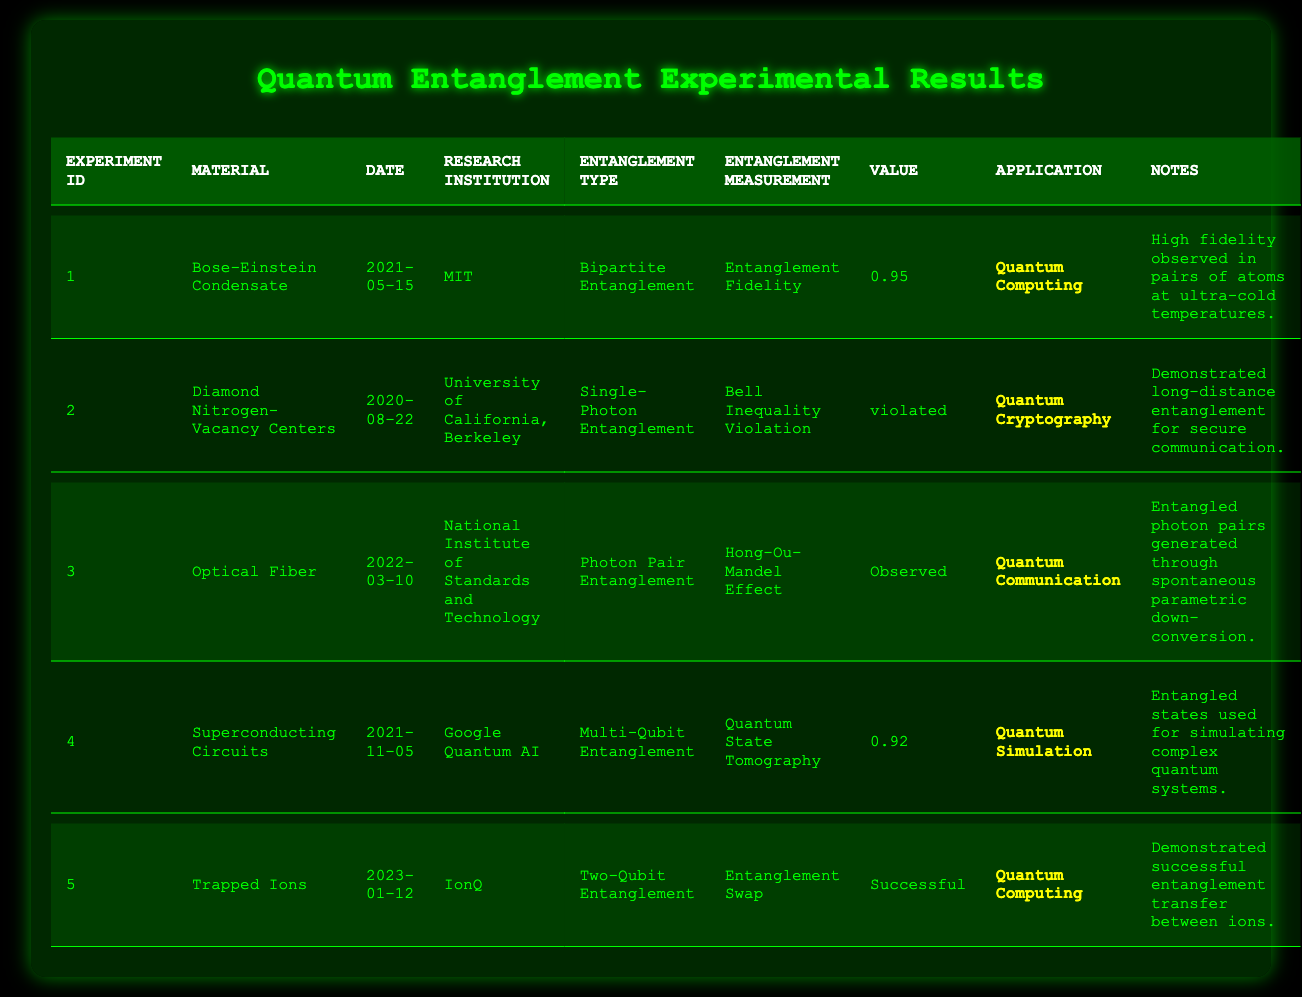What is the material used in experiment ID 2? Referring to the table, in the row labeled with experiment ID 2, the material is listed as "Diamond Nitrogen-Vacancy Centers."
Answer: Diamond Nitrogen-Vacancy Centers Which research institution conducted the experiment with the highest entanglement measurement value? Highlighting the experiment rows, the highest value is 0.95 from experiment ID 1 by MIT.
Answer: MIT What was the application for the material "Optical Fiber"? In the table, the application associated with "Optical Fiber" is mentioned as "Quantum Communication".
Answer: Quantum Communication Was the entanglement measurement for "Bose-Einstein Condensate" a numerical value? Checking the row for "Bose-Einstein Condensate," the entanglement measurement is 0.95 which is a numerical value, so the answer is yes.
Answer: Yes What is the average value of entanglement measurements for all experiments with numerical values? The numerical values are 0.95, 0.92. The sum is 0.95 + 0.92 = 1.87. There are 2 values, so the average is 1.87 / 2 = 0.935.
Answer: 0.935 For which application was the "Entanglement Swap" used? Referring to the data in the table, "Entanglement Swap" is used in the application for "Quantum Computing."
Answer: Quantum Computing Which experiment demonstrated a successful entanglement transfer? In the table, experiment ID 5 listed "Successful" under the entanglement measurement, indicating a successful entanglement transfer.
Answer: Experiment ID 5 How many experiments were conducted in 2021? A review of the table reveals that there are three entries from the year 2021: experiment IDs 1, 4, and 5. Thus, the count is three.
Answer: 3 What type of entanglement was used in experiment ID 4? Looking at experiment ID 4, the type of entanglement specified is "Multi-Qubit Entanglement."
Answer: Multi-Qubit Entanglement Was there a demonstration of long-distance entanglement for secure communication? Review of experiment ID 2 shows it states the demonstration of long-distance entanglement for secure communication, confirming that it did occur.
Answer: Yes 